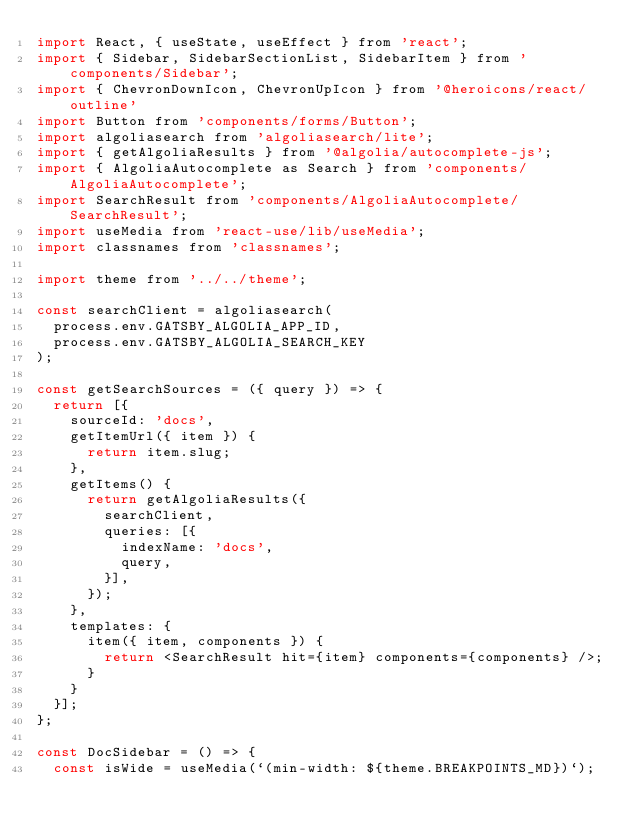Convert code to text. <code><loc_0><loc_0><loc_500><loc_500><_JavaScript_>import React, { useState, useEffect } from 'react';
import { Sidebar, SidebarSectionList, SidebarItem } from 'components/Sidebar';
import { ChevronDownIcon, ChevronUpIcon } from '@heroicons/react/outline'
import Button from 'components/forms/Button';
import algoliasearch from 'algoliasearch/lite';
import { getAlgoliaResults } from '@algolia/autocomplete-js';
import { AlgoliaAutocomplete as Search } from 'components/AlgoliaAutocomplete';
import SearchResult from 'components/AlgoliaAutocomplete/SearchResult';
import useMedia from 'react-use/lib/useMedia';
import classnames from 'classnames';

import theme from '../../theme';

const searchClient = algoliasearch(
  process.env.GATSBY_ALGOLIA_APP_ID,
  process.env.GATSBY_ALGOLIA_SEARCH_KEY
);

const getSearchSources = ({ query }) => {
  return [{
    sourceId: 'docs',
    getItemUrl({ item }) {
      return item.slug;
    },
    getItems() {
      return getAlgoliaResults({
        searchClient,
        queries: [{
          indexName: 'docs',
          query,
        }],
      });
    },
    templates: {
      item({ item, components }) {
        return <SearchResult hit={item} components={components} />;
      }
    }
  }];
};

const DocSidebar = () => {
  const isWide = useMedia(`(min-width: ${theme.BREAKPOINTS_MD})`);</code> 